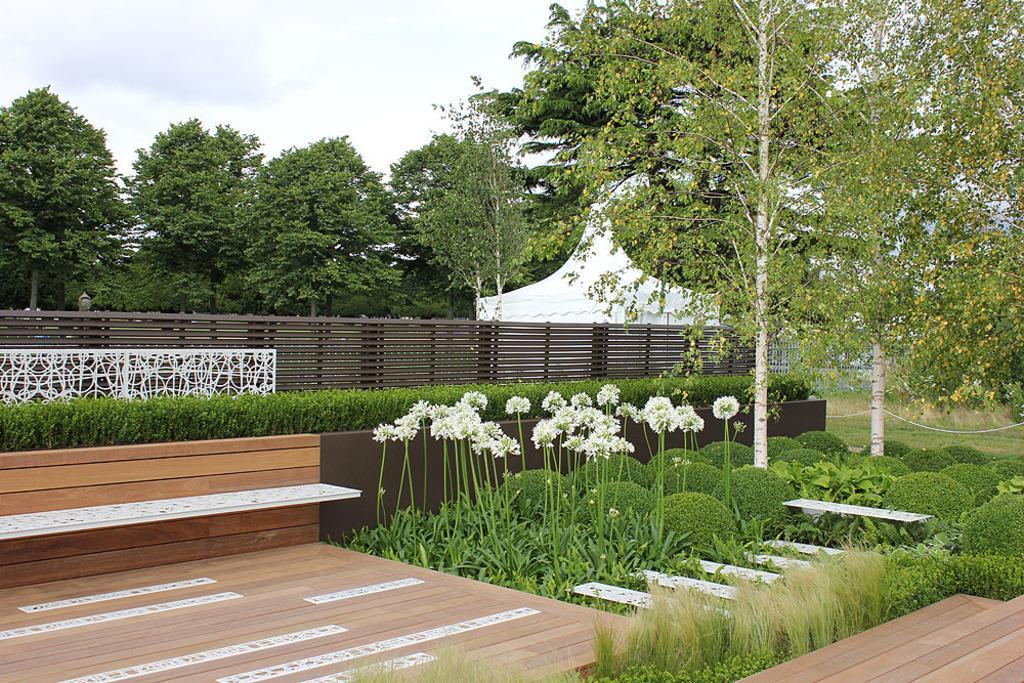Could you give a brief overview of what you see in this image? This place is looking like a garden. In the bottom right there is a wooden plank. On the left side there is a bench and also there is a fencing. In this image I can see many plants and trees. In the background there is a building. At the top of the image I can see the sky. 